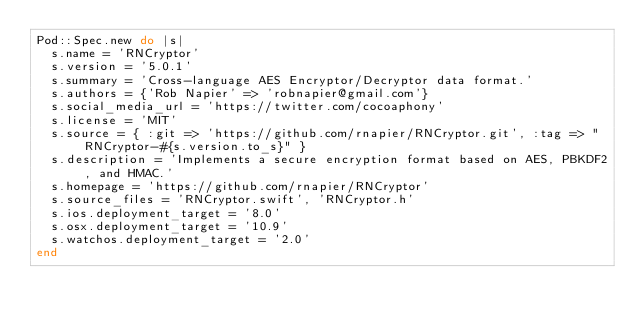Convert code to text. <code><loc_0><loc_0><loc_500><loc_500><_Ruby_>Pod::Spec.new do |s|
	s.name = 'RNCryptor'
	s.version = '5.0.1'
	s.summary = 'Cross-language AES Encryptor/Decryptor data format.'
	s.authors = {'Rob Napier' => 'robnapier@gmail.com'}
	s.social_media_url = 'https://twitter.com/cocoaphony'
	s.license = 'MIT'
	s.source = { :git => 'https://github.com/rnapier/RNCryptor.git', :tag => "RNCryptor-#{s.version.to_s}" }
	s.description = 'Implements a secure encryption format based on AES, PBKDF2, and HMAC.'
	s.homepage = 'https://github.com/rnapier/RNCryptor'
	s.source_files = 'RNCryptor.swift', 'RNCryptor.h'
	s.ios.deployment_target = '8.0'
	s.osx.deployment_target = '10.9'
	s.watchos.deployment_target = '2.0'
end
</code> 